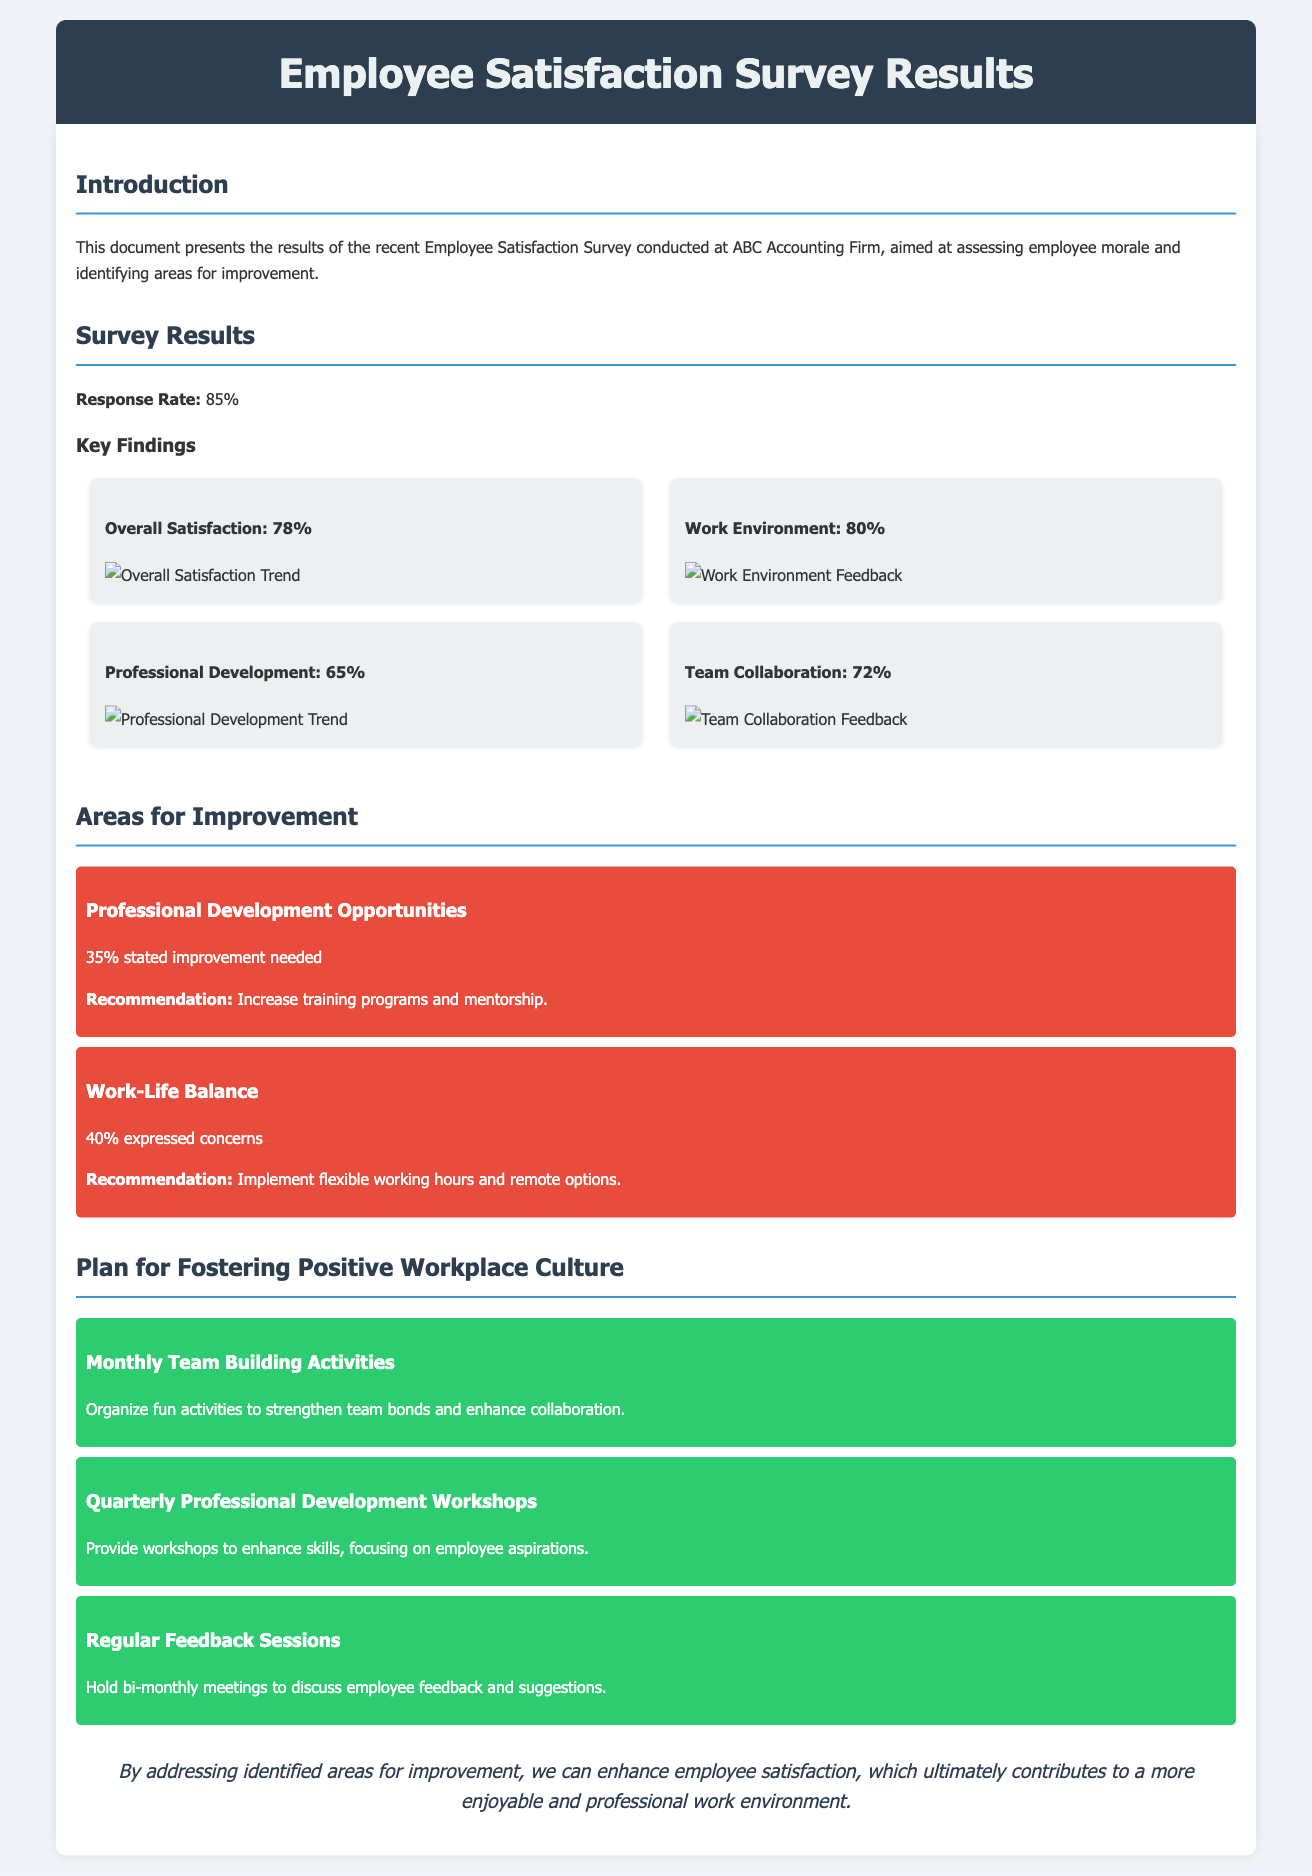What is the response rate of the survey? The response rate is a key metric showing the percentage of employees who participated in the survey, which is given as 85%.
Answer: 85% What percentage of employees are satisfied overall? This percentage is specifically stated in the survey results section, indicating the level of overall employee satisfaction, which is mentioned as 78%.
Answer: 78% What area received the lowest satisfaction rating? By comparing the percentages, we identify the area with the lowest satisfaction rating, which is Professional Development.
Answer: Professional Development How many employees expressed concerns about work-life balance? The document specifies that 40% of respondents expressed concerns, indicating a significant area for improvement.
Answer: 40% What is one recommendation for improving professional development opportunities? The recommendations are provided for each area of improvement, one being to increase training programs and mentorship for professional development.
Answer: Increase training programs and mentorship What kind of activities are suggested for fostering a positive workplace culture? The initiatives mentioned provide a way to enhance workplace culture, including organizing monthly team-building activities.
Answer: Monthly Team Building Activities What is the purpose of the regular feedback sessions? The document highlights that these sessions aim to facilitate discussions about employee feedback and suggestions, ensuring their voices are heard.
Answer: Discuss employee feedback and suggestions What is the main conclusion drawn from the survey results? The conclusion summarizes the significance of addressing areas for improvement to enhance employee satisfaction and contribute to a better work environment.
Answer: Enhance employee satisfaction What is the percentage of respondents that indicated a need for improvement in professional development? This percentage indicates how many employees feel that changes are necessary in this area, specifically noted as 35%.
Answer: 35% 